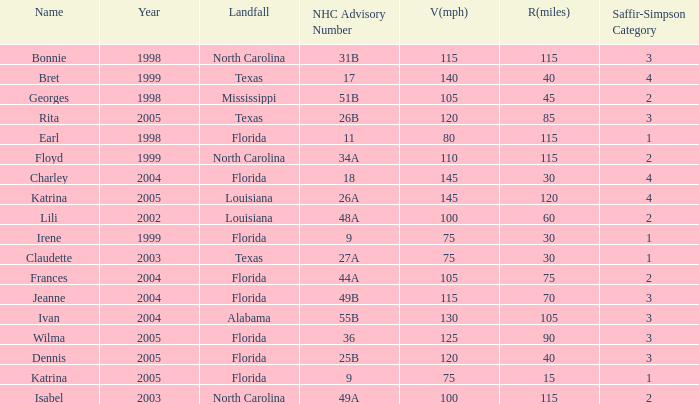What was the lowest V(mph) for a Saffir-Simpson of 4 in 2005? 145.0. 